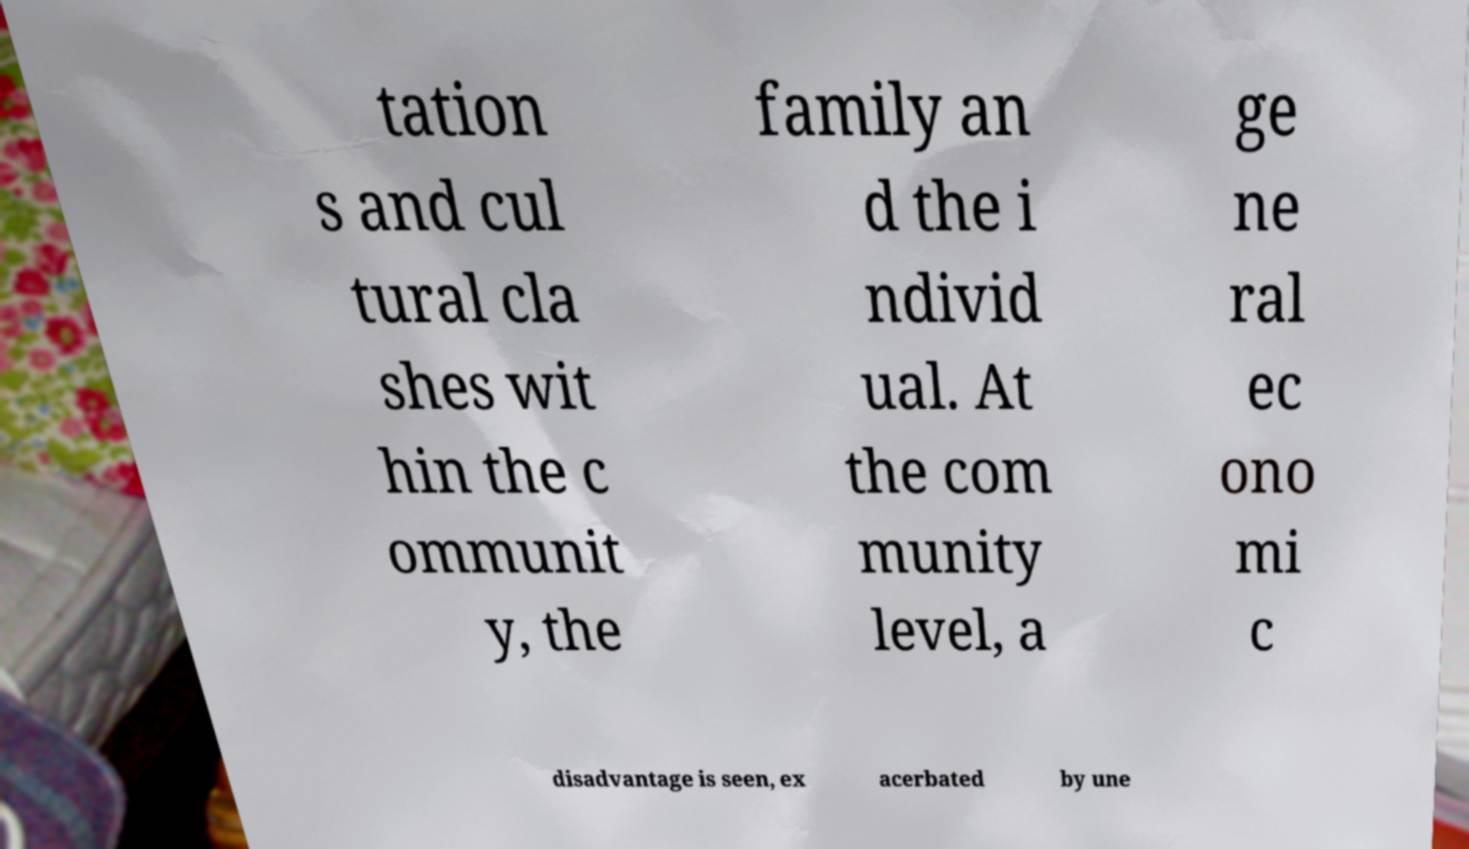I need the written content from this picture converted into text. Can you do that? tation s and cul tural cla shes wit hin the c ommunit y, the family an d the i ndivid ual. At the com munity level, a ge ne ral ec ono mi c disadvantage is seen, ex acerbated by une 